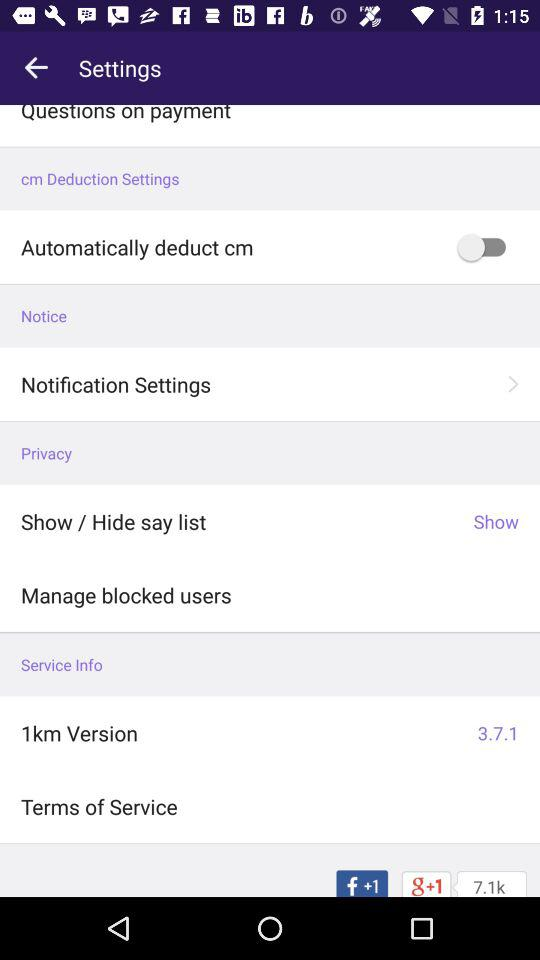How can I find more information about the terms of service for '1km'? To find more information about the '1km' terms of service, you can usually scroll down to the bottom of the app's settings menu where you found '1km Version'. There should be a link or section titled 'Terms of Service' that will provide detailed legal and usage information regarding the app. 